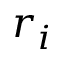Convert formula to latex. <formula><loc_0><loc_0><loc_500><loc_500>r _ { i }</formula> 